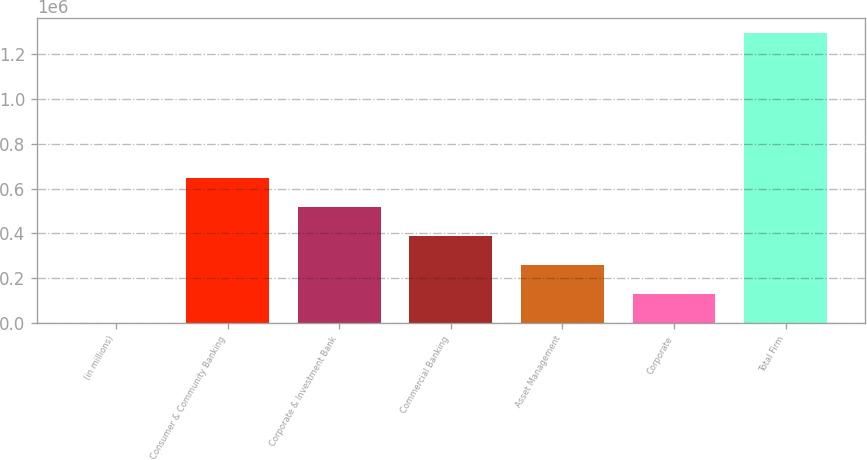<chart> <loc_0><loc_0><loc_500><loc_500><bar_chart><fcel>(in millions)<fcel>Consumer & Community Banking<fcel>Corporate & Investment Bank<fcel>Commercial Banking<fcel>Asset Management<fcel>Corporate<fcel>Total Firm<nl><fcel>2015<fcel>648902<fcel>519524<fcel>390147<fcel>260770<fcel>131392<fcel>1.29579e+06<nl></chart> 